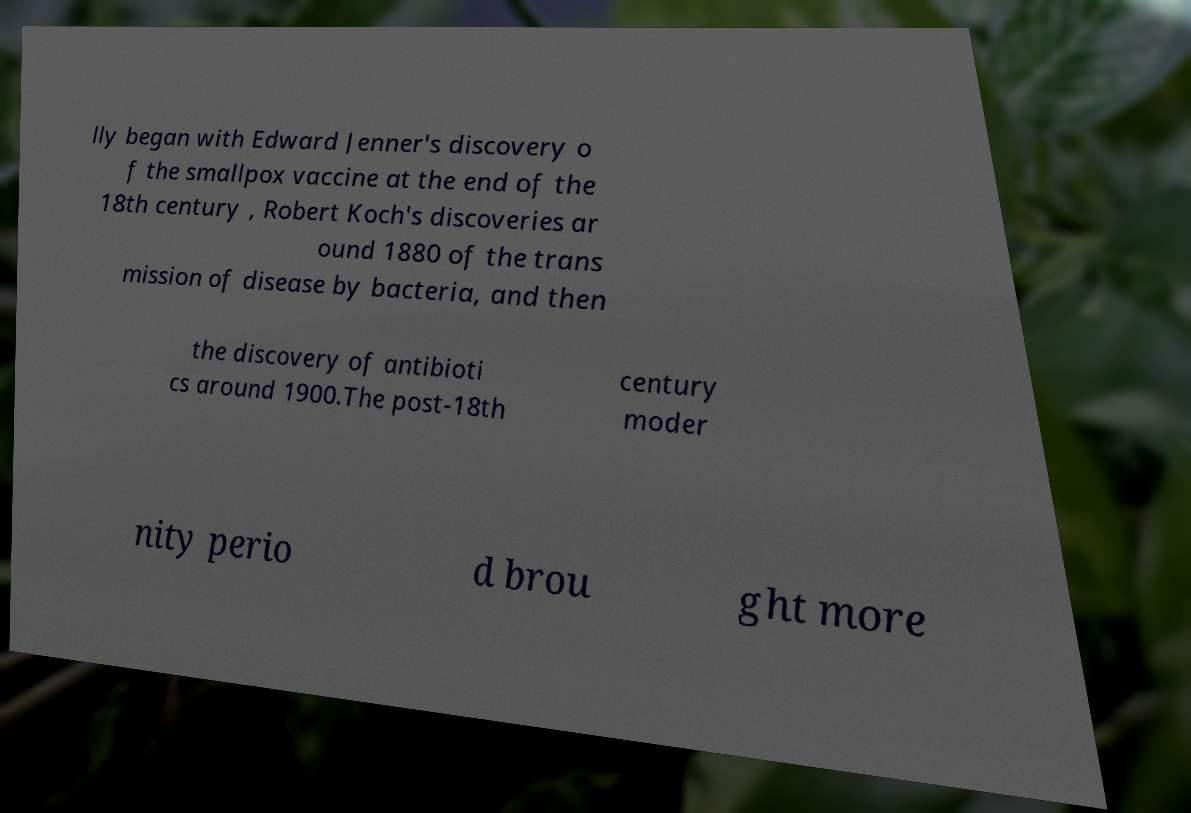What messages or text are displayed in this image? I need them in a readable, typed format. lly began with Edward Jenner's discovery o f the smallpox vaccine at the end of the 18th century , Robert Koch's discoveries ar ound 1880 of the trans mission of disease by bacteria, and then the discovery of antibioti cs around 1900.The post-18th century moder nity perio d brou ght more 